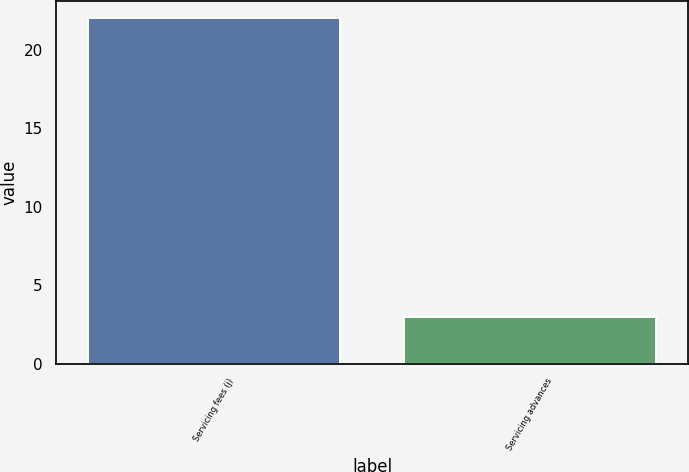Convert chart to OTSL. <chart><loc_0><loc_0><loc_500><loc_500><bar_chart><fcel>Servicing fees (j)<fcel>Servicing advances<nl><fcel>22<fcel>3<nl></chart> 